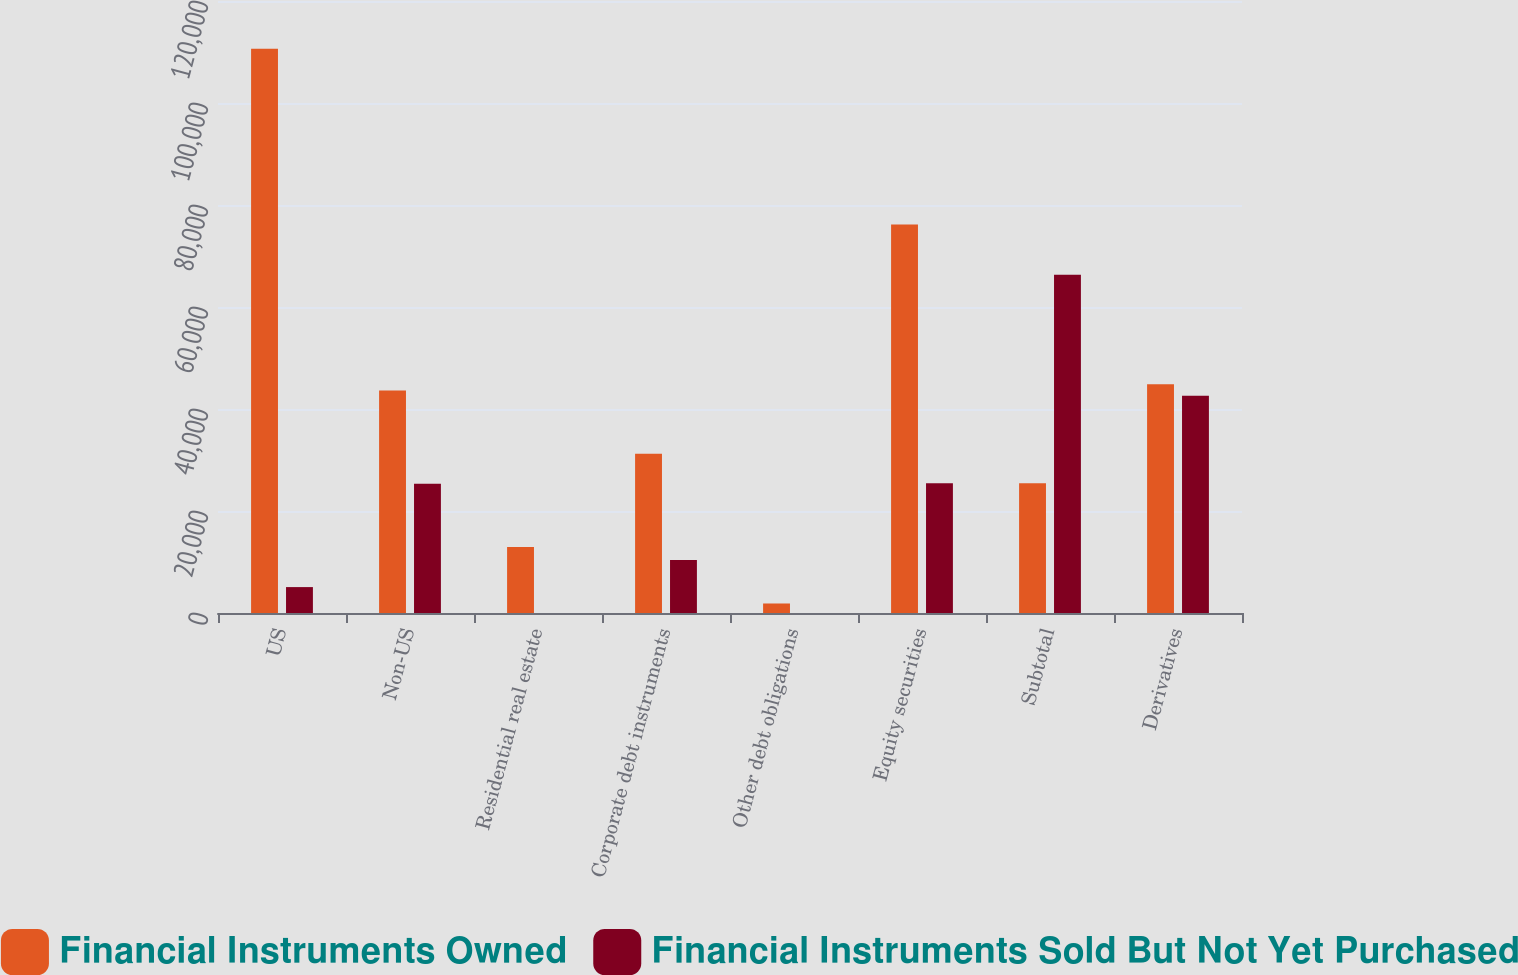Convert chart. <chart><loc_0><loc_0><loc_500><loc_500><stacked_bar_chart><ecel><fcel>US<fcel>Non-US<fcel>Residential real estate<fcel>Corporate debt instruments<fcel>Other debt obligations<fcel>Equity securities<fcel>Subtotal<fcel>Derivatives<nl><fcel>Financial Instruments Owned<fcel>110616<fcel>43607<fcel>12949<fcel>31207<fcel>1864<fcel>76170<fcel>25463<fcel>44846<nl><fcel>Financial Instruments Sold But Not Yet Purchased<fcel>5080<fcel>25347<fcel>1<fcel>10411<fcel>1<fcel>25463<fcel>66303<fcel>42594<nl></chart> 